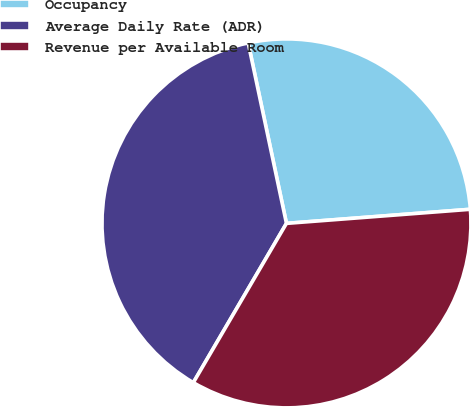<chart> <loc_0><loc_0><loc_500><loc_500><pie_chart><fcel>Occupancy<fcel>Average Daily Rate (ADR)<fcel>Revenue per Available Room<nl><fcel>27.11%<fcel>38.25%<fcel>34.64%<nl></chart> 